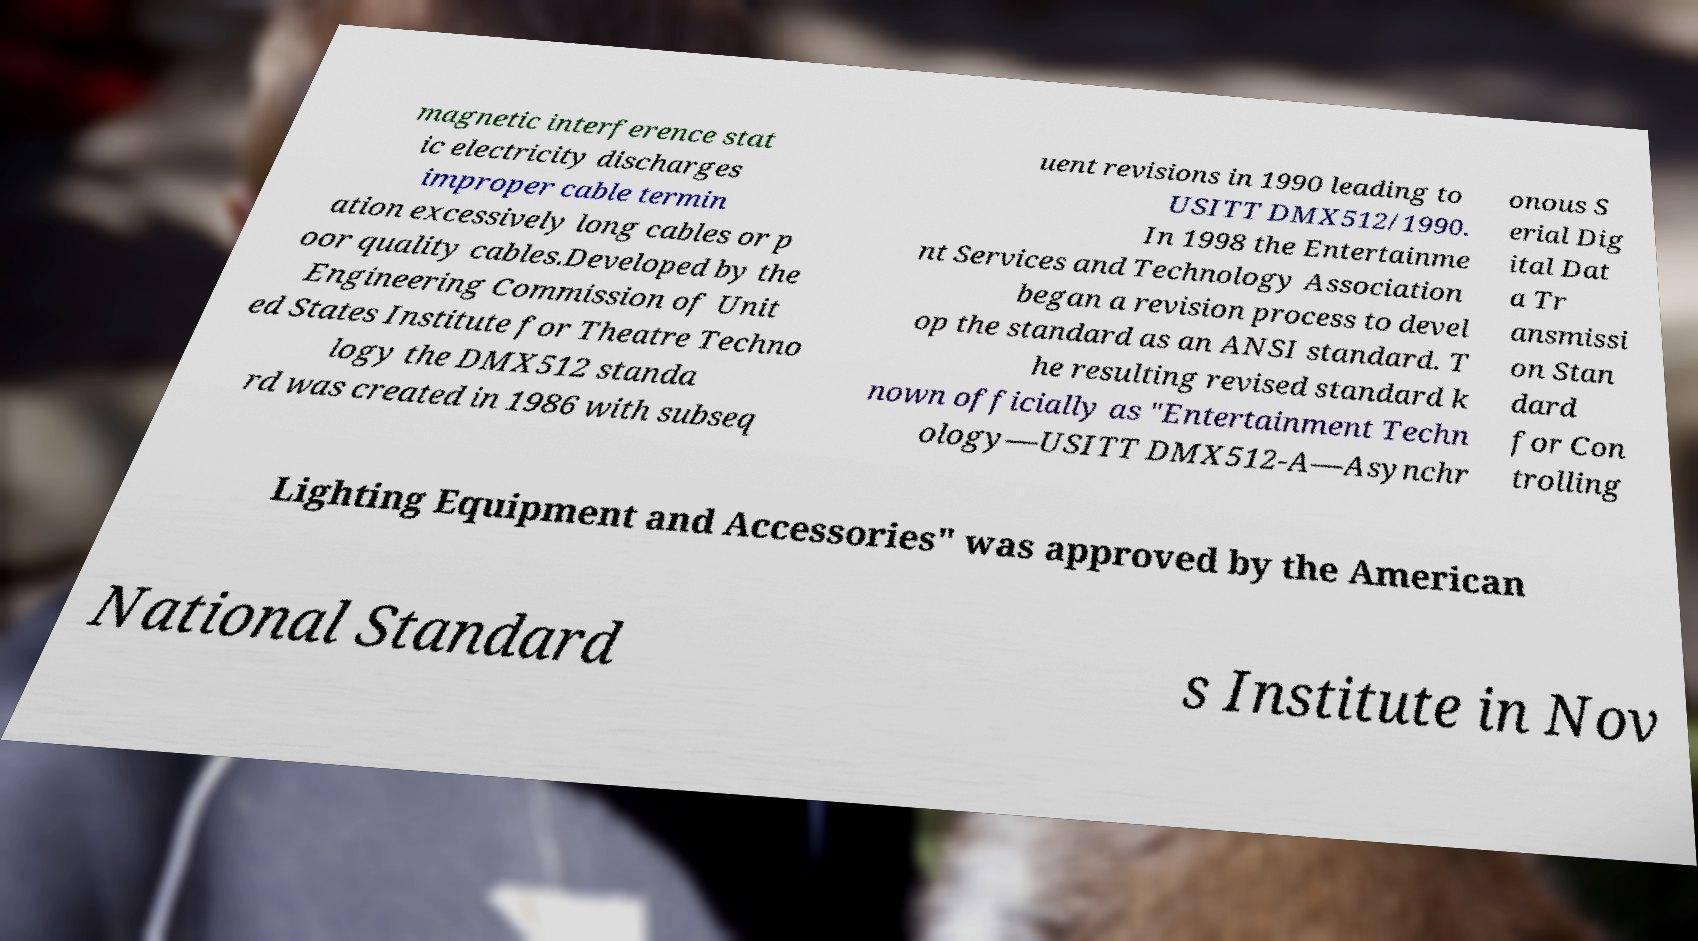Can you read and provide the text displayed in the image?This photo seems to have some interesting text. Can you extract and type it out for me? magnetic interference stat ic electricity discharges improper cable termin ation excessively long cables or p oor quality cables.Developed by the Engineering Commission of Unit ed States Institute for Theatre Techno logy the DMX512 standa rd was created in 1986 with subseq uent revisions in 1990 leading to USITT DMX512/1990. In 1998 the Entertainme nt Services and Technology Association began a revision process to devel op the standard as an ANSI standard. T he resulting revised standard k nown officially as "Entertainment Techn ology—USITT DMX512-A—Asynchr onous S erial Dig ital Dat a Tr ansmissi on Stan dard for Con trolling Lighting Equipment and Accessories" was approved by the American National Standard s Institute in Nov 